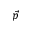Convert formula to latex. <formula><loc_0><loc_0><loc_500><loc_500>\vec { p }</formula> 